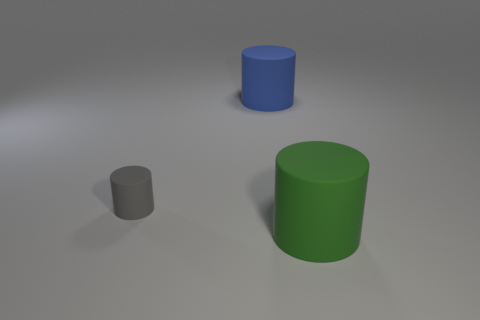Subtract all gray cylinders. Subtract all brown balls. How many cylinders are left? 2 Add 2 gray blocks. How many objects exist? 5 Subtract all big green matte objects. Subtract all tiny gray objects. How many objects are left? 1 Add 3 cylinders. How many cylinders are left? 6 Add 2 large yellow metallic spheres. How many large yellow metallic spheres exist? 2 Subtract 0 yellow cubes. How many objects are left? 3 